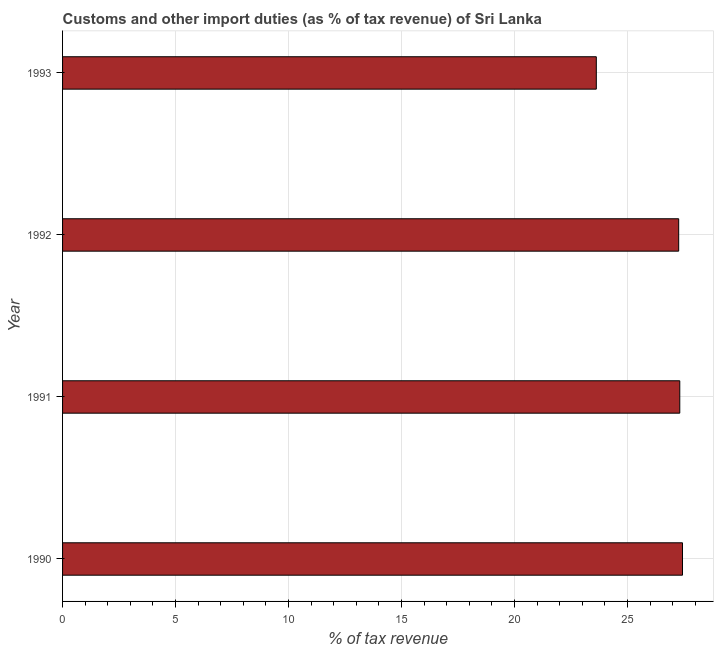Does the graph contain any zero values?
Provide a succinct answer. No. Does the graph contain grids?
Offer a very short reply. Yes. What is the title of the graph?
Offer a very short reply. Customs and other import duties (as % of tax revenue) of Sri Lanka. What is the label or title of the X-axis?
Give a very brief answer. % of tax revenue. What is the label or title of the Y-axis?
Your response must be concise. Year. What is the customs and other import duties in 1990?
Offer a very short reply. 27.44. Across all years, what is the maximum customs and other import duties?
Your answer should be compact. 27.44. Across all years, what is the minimum customs and other import duties?
Provide a short and direct response. 23.62. In which year was the customs and other import duties maximum?
Offer a very short reply. 1990. What is the sum of the customs and other import duties?
Provide a succinct answer. 105.64. What is the difference between the customs and other import duties in 1991 and 1992?
Provide a short and direct response. 0.05. What is the average customs and other import duties per year?
Offer a very short reply. 26.41. What is the median customs and other import duties?
Provide a succinct answer. 27.29. In how many years, is the customs and other import duties greater than 7 %?
Offer a terse response. 4. What is the ratio of the customs and other import duties in 1990 to that in 1993?
Provide a short and direct response. 1.16. Is the customs and other import duties in 1992 less than that in 1993?
Make the answer very short. No. What is the difference between the highest and the second highest customs and other import duties?
Provide a succinct answer. 0.12. Is the sum of the customs and other import duties in 1990 and 1993 greater than the maximum customs and other import duties across all years?
Provide a succinct answer. Yes. What is the difference between the highest and the lowest customs and other import duties?
Ensure brevity in your answer.  3.81. How many bars are there?
Provide a succinct answer. 4. Are all the bars in the graph horizontal?
Offer a very short reply. Yes. How many years are there in the graph?
Your answer should be compact. 4. What is the % of tax revenue of 1990?
Your response must be concise. 27.44. What is the % of tax revenue of 1991?
Give a very brief answer. 27.31. What is the % of tax revenue in 1992?
Offer a very short reply. 27.27. What is the % of tax revenue in 1993?
Your answer should be compact. 23.62. What is the difference between the % of tax revenue in 1990 and 1991?
Provide a short and direct response. 0.12. What is the difference between the % of tax revenue in 1990 and 1992?
Give a very brief answer. 0.17. What is the difference between the % of tax revenue in 1990 and 1993?
Your answer should be compact. 3.81. What is the difference between the % of tax revenue in 1991 and 1992?
Provide a succinct answer. 0.05. What is the difference between the % of tax revenue in 1991 and 1993?
Your response must be concise. 3.69. What is the difference between the % of tax revenue in 1992 and 1993?
Make the answer very short. 3.65. What is the ratio of the % of tax revenue in 1990 to that in 1992?
Offer a very short reply. 1.01. What is the ratio of the % of tax revenue in 1990 to that in 1993?
Offer a very short reply. 1.16. What is the ratio of the % of tax revenue in 1991 to that in 1992?
Ensure brevity in your answer.  1. What is the ratio of the % of tax revenue in 1991 to that in 1993?
Give a very brief answer. 1.16. What is the ratio of the % of tax revenue in 1992 to that in 1993?
Provide a short and direct response. 1.15. 